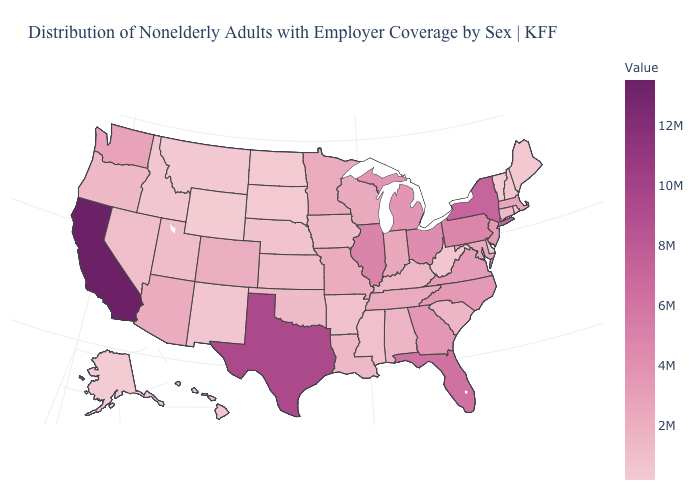Does California have the highest value in the USA?
Write a very short answer. Yes. Among the states that border Rhode Island , does Connecticut have the lowest value?
Keep it brief. Yes. Does the map have missing data?
Concise answer only. No. Is the legend a continuous bar?
Answer briefly. Yes. Does New Jersey have the highest value in the USA?
Answer briefly. No. Does Massachusetts have the lowest value in the Northeast?
Answer briefly. No. 